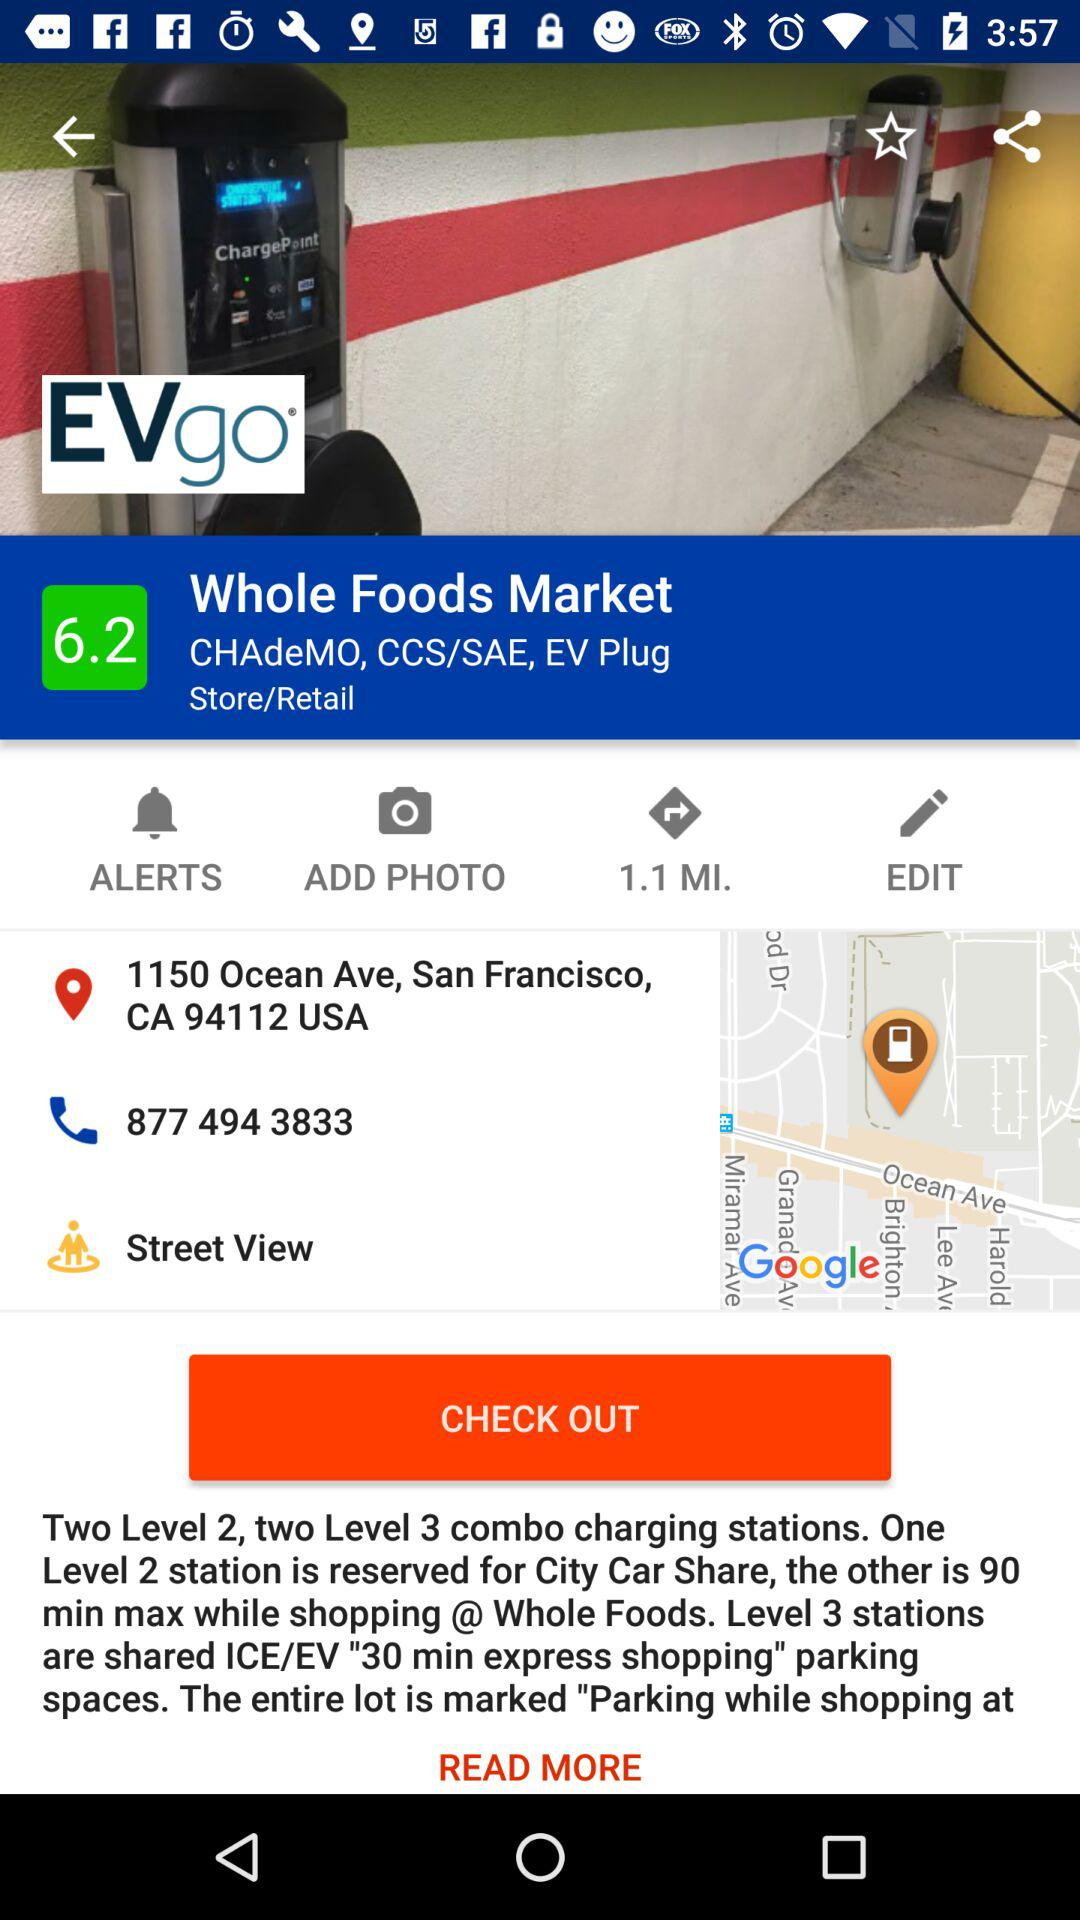What is the time duration of level 2 order?
When the provided information is insufficient, respond with <no answer>. <no answer> 